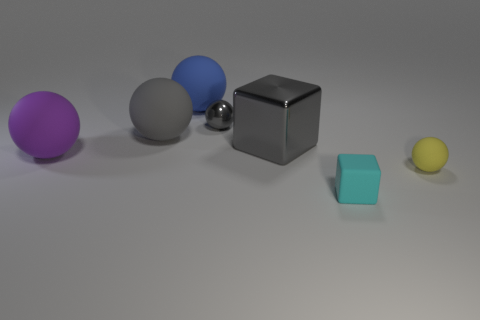Subtract all purple spheres. How many spheres are left? 4 Subtract all yellow balls. How many balls are left? 4 Subtract 1 balls. How many balls are left? 4 Subtract all purple spheres. Subtract all brown cubes. How many spheres are left? 4 Add 1 large red balls. How many objects exist? 8 Subtract all cubes. How many objects are left? 5 Subtract 0 green spheres. How many objects are left? 7 Subtract all large purple matte balls. Subtract all big purple rubber things. How many objects are left? 5 Add 5 yellow matte things. How many yellow matte things are left? 6 Add 5 small brown rubber objects. How many small brown rubber objects exist? 5 